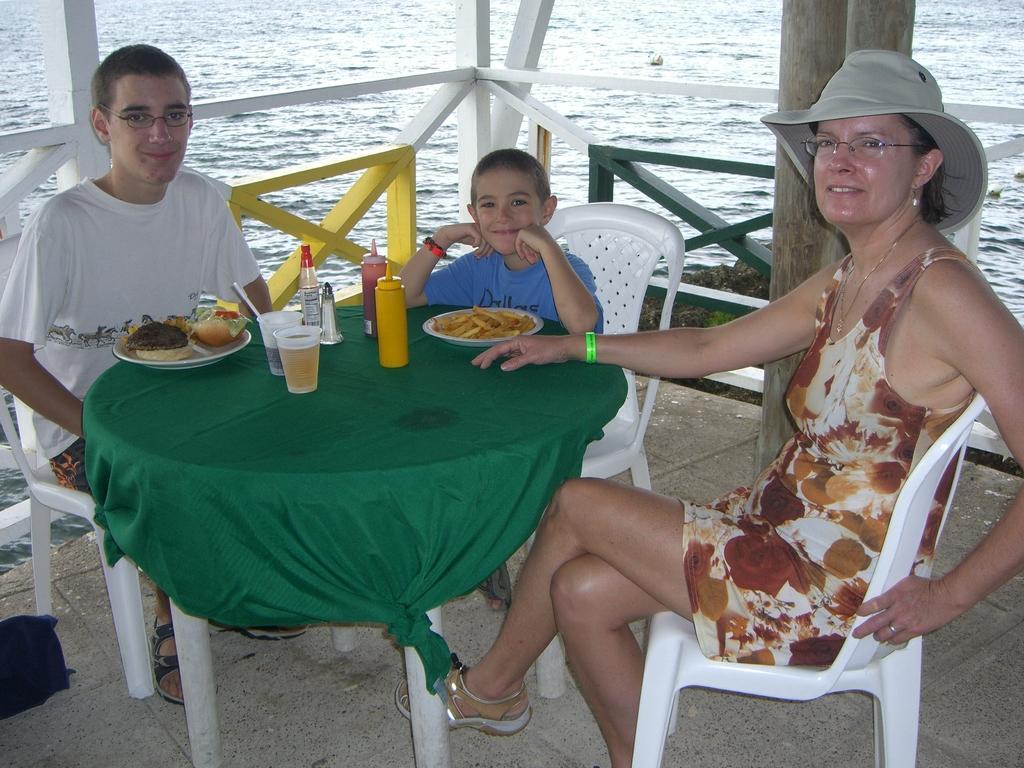Describe this image in one or two sentences. In this image In the middle there is a table covered with cloth on that there is a plate, cups, bottles and food. Around that there are three people on that on the right there is a woman she wear dress, spectacles and hat. On the left there is a boy he wear t shirt and trouser. In the middle there is a boy he is smiling. In the background there is a water. 